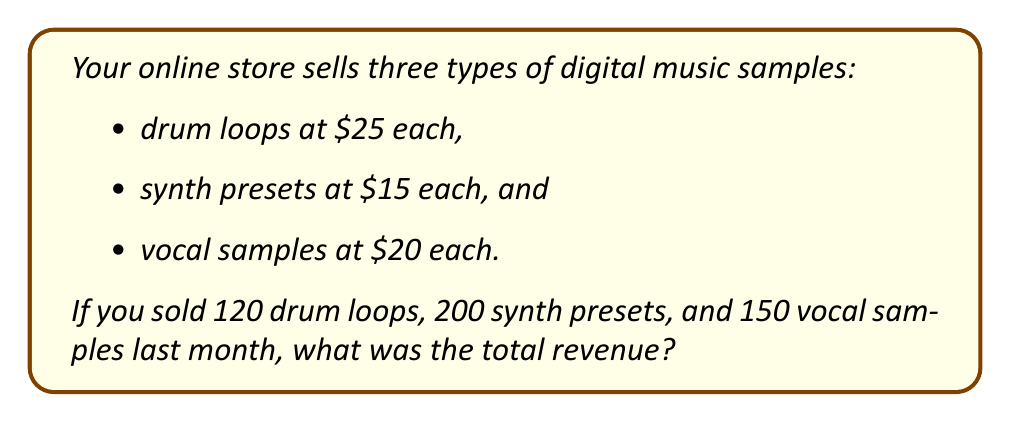Could you help me with this problem? Let's break this down step-by-step:

1. Calculate the revenue from drum loops:
   $$ \text{Drum loop revenue} = \text{Price per drum loop} \times \text{Number of drum loops sold} $$
   $$ = $25 \times 120 = $3,000 $$

2. Calculate the revenue from synth presets:
   $$ \text{Synth preset revenue} = \text{Price per synth preset} \times \text{Number of synth presets sold} $$
   $$ = $15 \times 200 = $3,000 $$

3. Calculate the revenue from vocal samples:
   $$ \text{Vocal sample revenue} = \text{Price per vocal sample} \times \text{Number of vocal samples sold} $$
   $$ = $20 \times 150 = $3,000 $$

4. Sum up the revenue from all products to get the total revenue:
   $$ \text{Total revenue} = \text{Drum loop revenue} + \text{Synth preset revenue} + \text{Vocal sample revenue} $$
   $$ = $3,000 + $3,000 + $3,000 = $9,000 $$

Therefore, the total revenue from all product sales last month was $9,000.
Answer: $9,000 